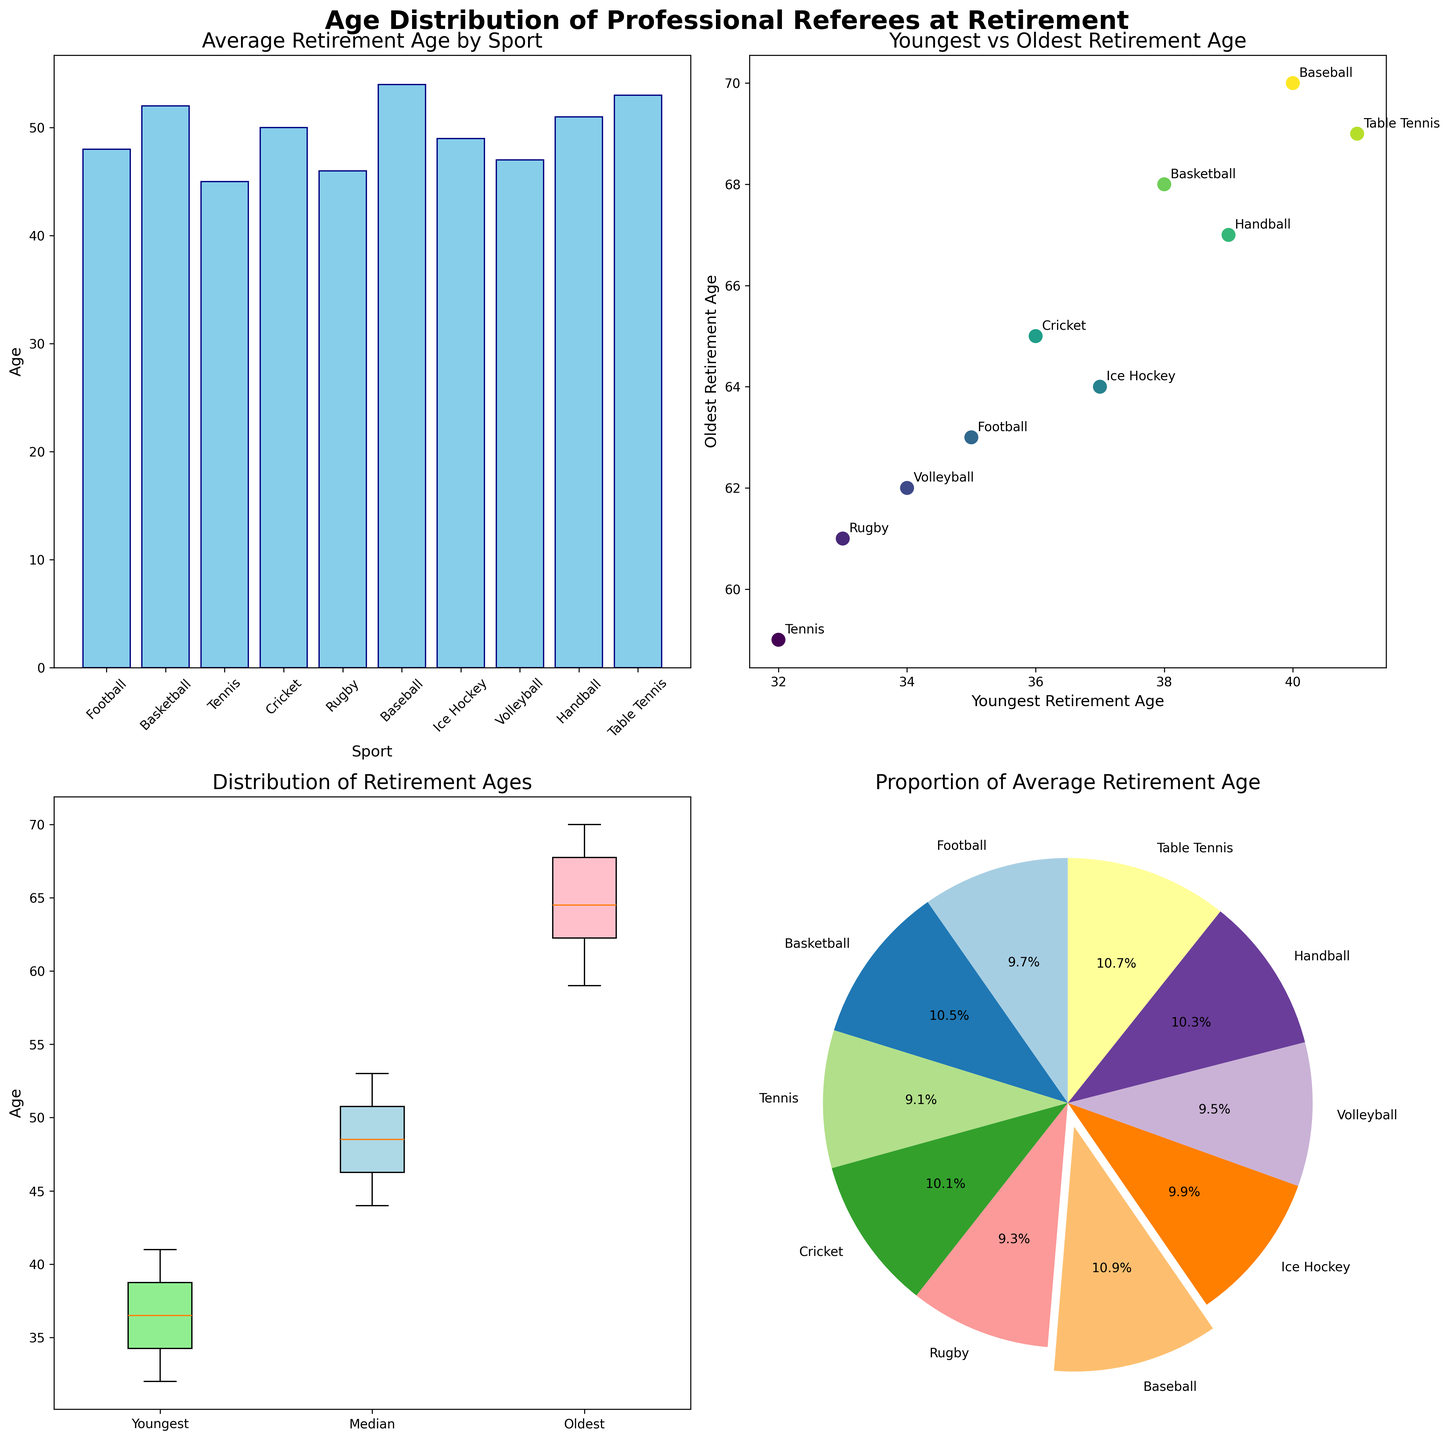What's the average retirement age for referees in the sports listed? The bar plot on the top-left shows the average retirement ages for the different sports. By looking at the height of the bars, we see: Football (48), Basketball (52), Tennis (45), Cricket (50), Rugby (46), Baseball (54), Ice Hockey (49), Volleyball (47), Handball (51), and Table Tennis (53).
Answer: Varies per sport (ranging from 45 to 54) What is the youngest retirement age shown in the figure? The scatter plot on the top-right shows the youngest versus oldest retirement ages. By looking at the x-axis, the lowest value for the youngest retirement age is 32, associated with Tennis.
Answer: 32 Which sport has referees with the longest average retirement age? The bar plot indicates that Baseball referees in Japan have the highest average retirement age, represented by the tallest bar.
Answer: Baseball How do the youngest and oldest retirement ages compare across different sports? The scatter plot directly compares youngest and oldest retirement ages for various sports. Each sport has a different position, with annotations indicating the sports and their respective youngest and oldest ages. For example, Football has a youngest age of 35 and oldest age of 63, while Baseball has 40 and 70.
Answer: Varied; Baseball has the highest range (40 to 70) What's the median retirement age for referees in different sports? The box plot in the bottom-left represents three distributions (Youngest, Median, and Oldest retirement ages). The median ages are represented by the middle line in the box plot: Football (47), Basketball (51), Tennis (44), Cricket (49), Rugby (45), Baseball (53), Ice Hockey (48), Volleyball (46), Handball (50), and Table Tennis (52).
Answer: Varies per sport (ranging from 44 to 53) Which sport contributes the largest proportion to the average retirement age? The pie chart shows the contributions of different sports to the average retirement age. The slice representing Baseball is the largest, highlighting its contribution.
Answer: Baseball What is the color of the box plot representing the oldest retirement ages? In the box plot, the oldest retirement ages are indicated by the boxes filled with pink color (rightmost boxes).
Answer: Pink Which country is associated with the highest and lowest average retirement ages? From the bar plot, Baseball in Japan has the highest at 54, and Tennis in France has the lowest at 45.
Answer: Highest: Japan (Baseball); Lowest: France (Tennis) Does the sport with the highest average retirement age also have the highest oldest retirement age? Baseball has the highest average retirement age (54) and also the highest oldest retirement age (70), as seen in both the bar plot and the scatter plot.
Answer: Yes Are the proportions of referees' average retirement ages evenly distributed across sports? The pie chart shows that the proportions are not evenly distributed, with larger slices for sports with higher averages such as Baseball and smaller slices for lower averages such as Tennis.
Answer: No 